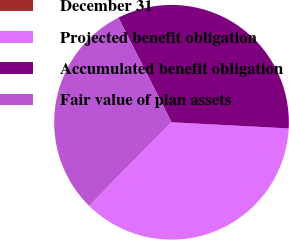Convert chart. <chart><loc_0><loc_0><loc_500><loc_500><pie_chart><fcel>December 31<fcel>Projected benefit obligation<fcel>Accumulated benefit obligation<fcel>Fair value of plan assets<nl><fcel>0.06%<fcel>36.53%<fcel>33.31%<fcel>30.1%<nl></chart> 